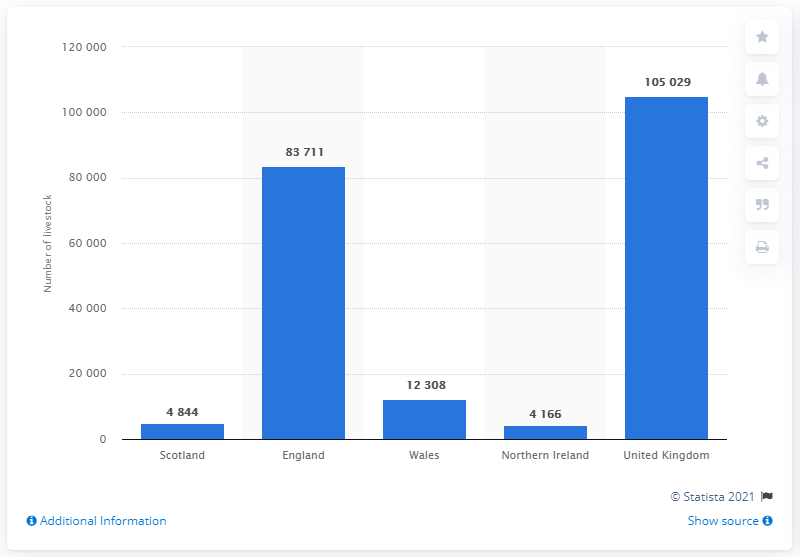Mention a couple of crucial points in this snapshot. In England in June 2017, there were 8,3711 goats and kids. 